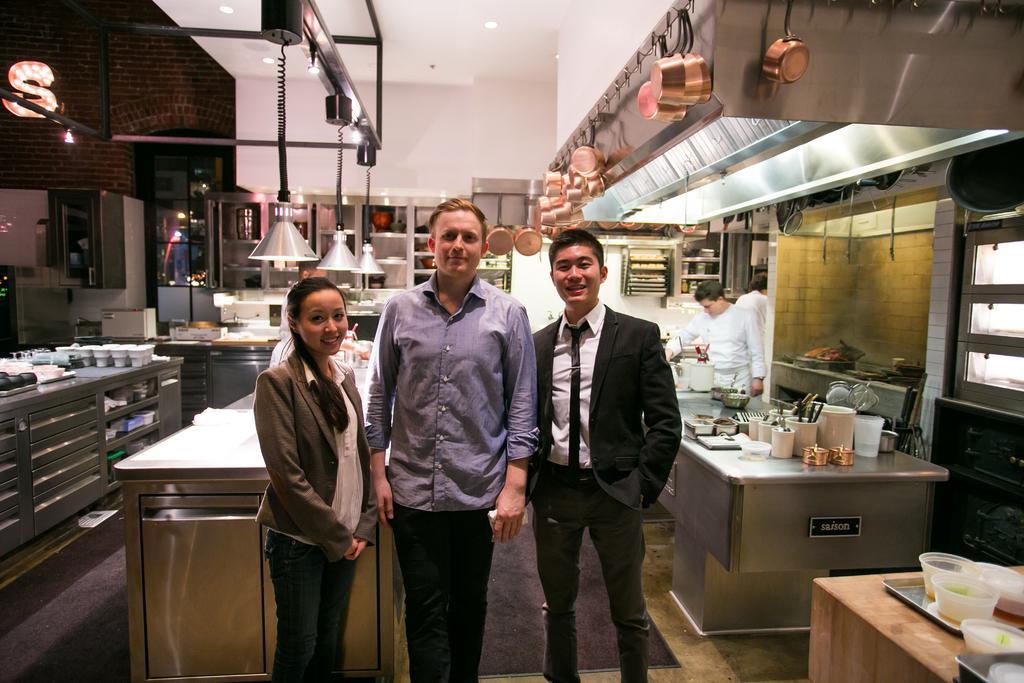Could you give a brief overview of what you see in this image? This picture is clicked inside the room. In the center we can see the three persons standing on the floor and we can see the table on the top of which some objects are placed and we can see the counters on the top of which utensils and many other objects are placed. At the top we can see the roof and the ceiling lights and we can see the lamps hanging on the metal rods and we can see the utensils and pans hanging on the wall and we can see the cabinets containing many number of objects and we can see the group of persons and some food items and many other objects. In the background we can see the lights, window, door and some other objects. 